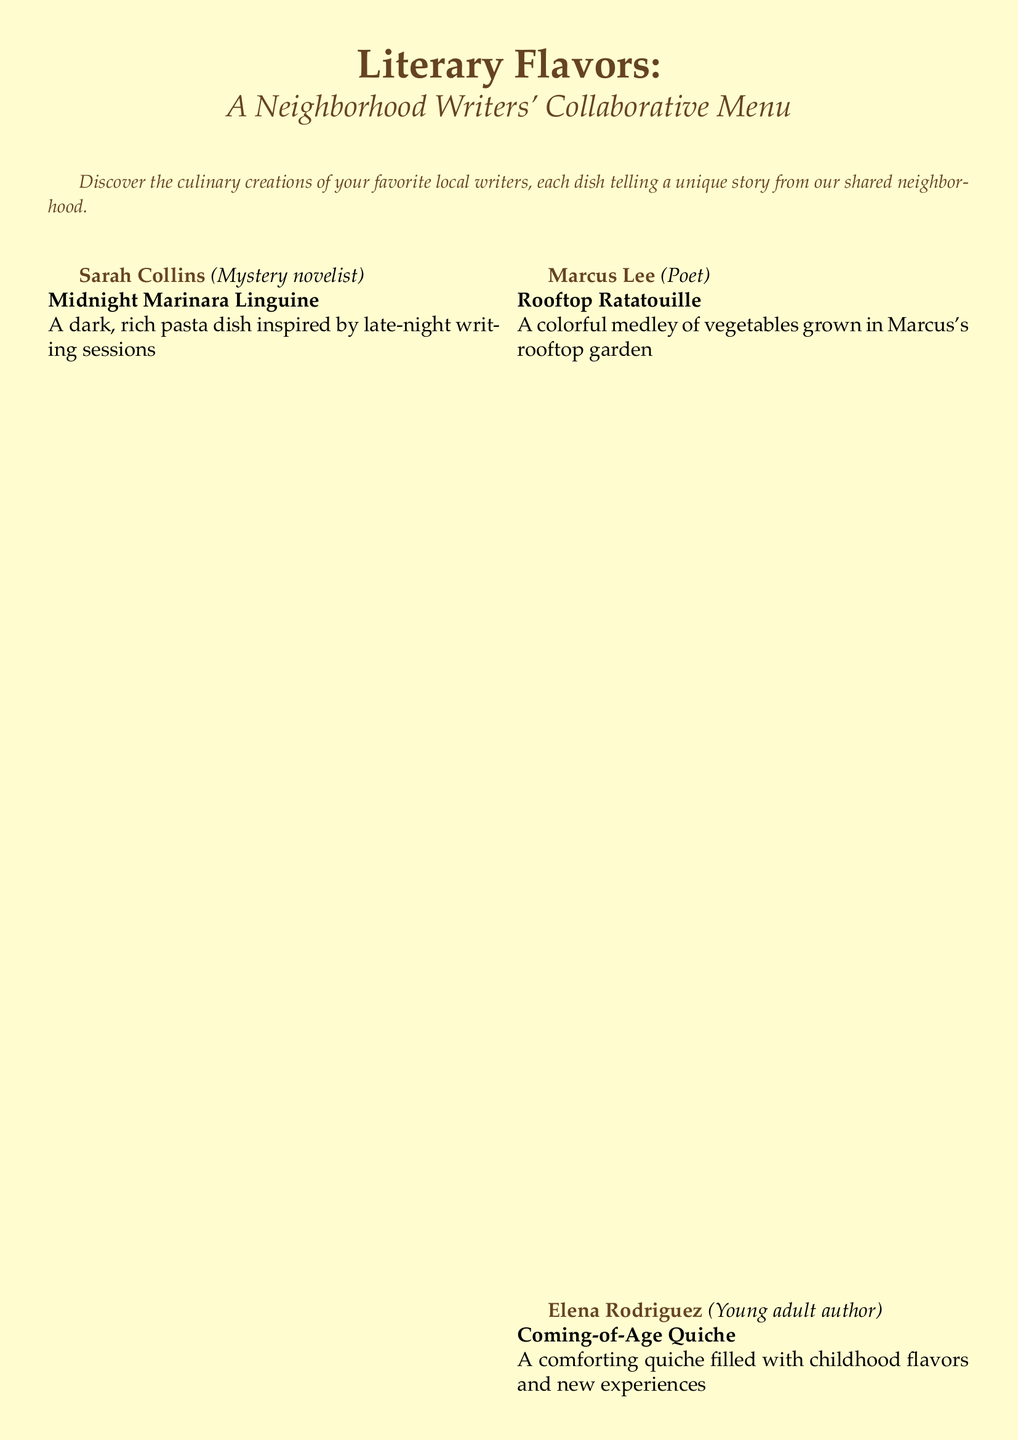What is the title of the menu? The title of the menu is prominently displayed at the top of the document, which is "Literary Flavors".
Answer: Literary Flavors Who contributed the Midnight Marinara Linguine? This dish is associated with a specific writer, which can be found in the description that follows the dish name, identifying Sarah Collins.
Answer: Sarah Collins What type of cuisine does Olivia Chen represent? The document indicates her role as a food blogger, which suggests a focus on culinary experiences.
Answer: Food blogger How many writers contributed to the menu? The individual contributions from each writer listed in the document help us determine this total, which is five.
Answer: Five What is the name of the dessert? The dessert section clearly labels a specific dish created in collaboration, titled "Collaborative Chocolate Tart".
Answer: Collaborative Chocolate Tart What is the primary influence of the Coming-of-Age Quiche? The dish's description includes an emotional connection to personal experiences and memories, which can be summarized as childhood flavors.
Answer: Childhood flavors Which dish features vegetables from a garden? The Rooftop Ratatouille is specifically noted for its ingredients sourced from Marcus's rooftop garden.
Answer: Rooftop Ratatouille What type of drink is mentioned as "Typewriter Fizz"? The beverages section lists various drinks, indicating "Typewriter Fizz" as one of the options available.
Answer: Typewriter Fizz What literary genre does David Thompson write in? The document explicitly states that David is a historical fiction writer, which informs us of his genre.
Answer: Historical fiction 